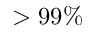<formula> <loc_0><loc_0><loc_500><loc_500>> 9 9 \%</formula> 